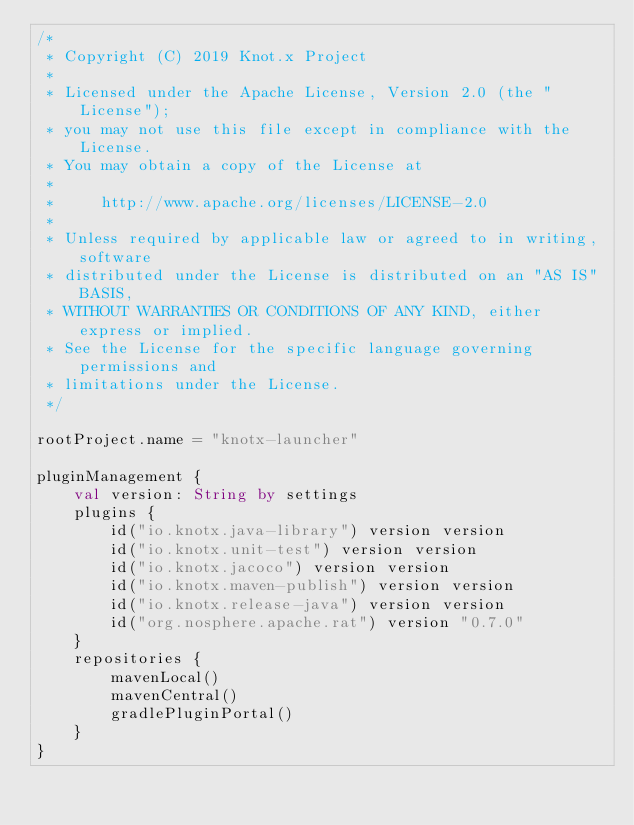<code> <loc_0><loc_0><loc_500><loc_500><_Kotlin_>/*
 * Copyright (C) 2019 Knot.x Project
 *
 * Licensed under the Apache License, Version 2.0 (the "License");
 * you may not use this file except in compliance with the License.
 * You may obtain a copy of the License at
 *
 *     http://www.apache.org/licenses/LICENSE-2.0
 *
 * Unless required by applicable law or agreed to in writing, software
 * distributed under the License is distributed on an "AS IS" BASIS,
 * WITHOUT WARRANTIES OR CONDITIONS OF ANY KIND, either express or implied.
 * See the License for the specific language governing permissions and
 * limitations under the License.
 */

rootProject.name = "knotx-launcher"

pluginManagement {
    val version: String by settings
    plugins {
        id("io.knotx.java-library") version version
        id("io.knotx.unit-test") version version
        id("io.knotx.jacoco") version version
        id("io.knotx.maven-publish") version version
        id("io.knotx.release-java") version version
        id("org.nosphere.apache.rat") version "0.7.0"
    }
    repositories {
        mavenLocal()
        mavenCentral()
        gradlePluginPortal()
    }
}</code> 